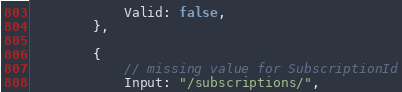<code> <loc_0><loc_0><loc_500><loc_500><_Go_>			Valid: false,
		},

		{
			// missing value for SubscriptionId
			Input: "/subscriptions/",</code> 